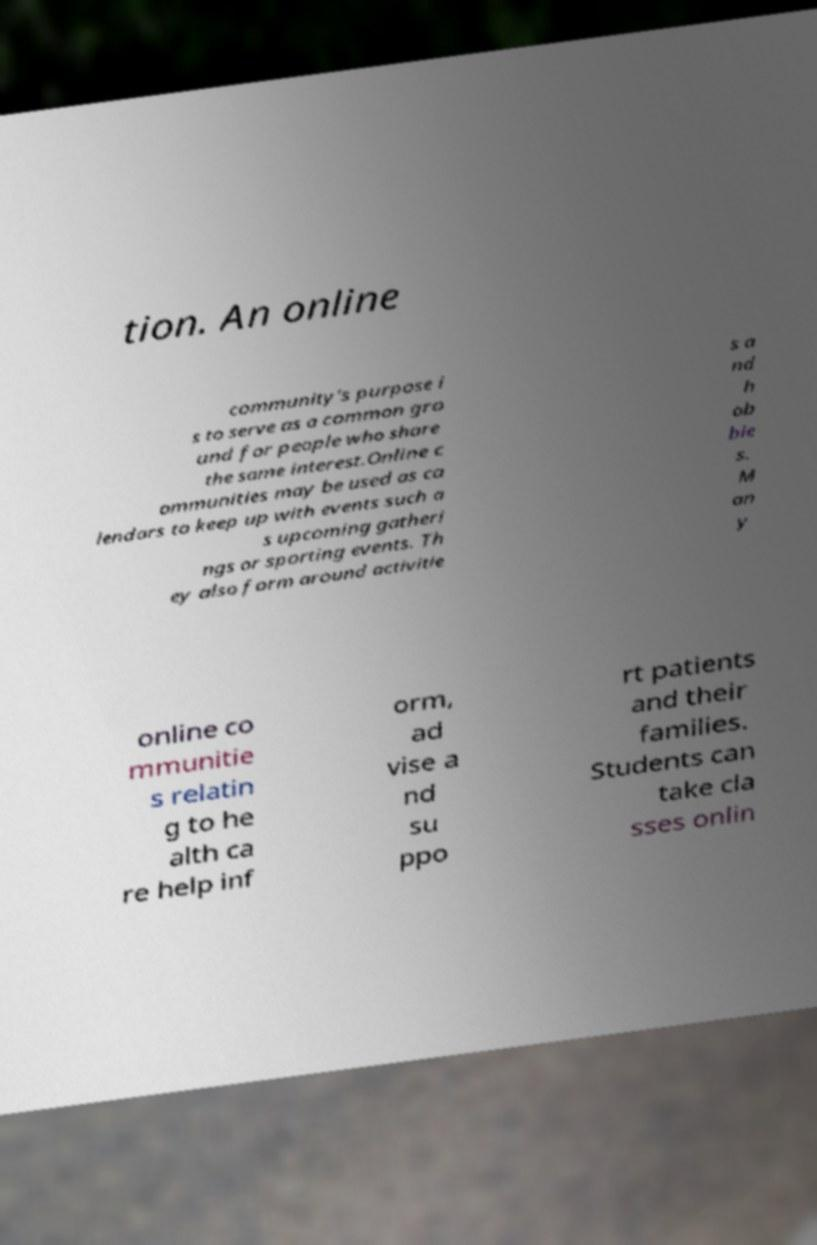Can you accurately transcribe the text from the provided image for me? tion. An online community's purpose i s to serve as a common gro und for people who share the same interest.Online c ommunities may be used as ca lendars to keep up with events such a s upcoming gatheri ngs or sporting events. Th ey also form around activitie s a nd h ob bie s. M an y online co mmunitie s relatin g to he alth ca re help inf orm, ad vise a nd su ppo rt patients and their families. Students can take cla sses onlin 